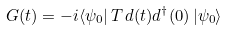Convert formula to latex. <formula><loc_0><loc_0><loc_500><loc_500>G ( t ) = - i \langle \psi _ { 0 } | \, T \, d ( t ) d ^ { \dagger } ( 0 ) \, | \psi _ { 0 } \rangle</formula> 